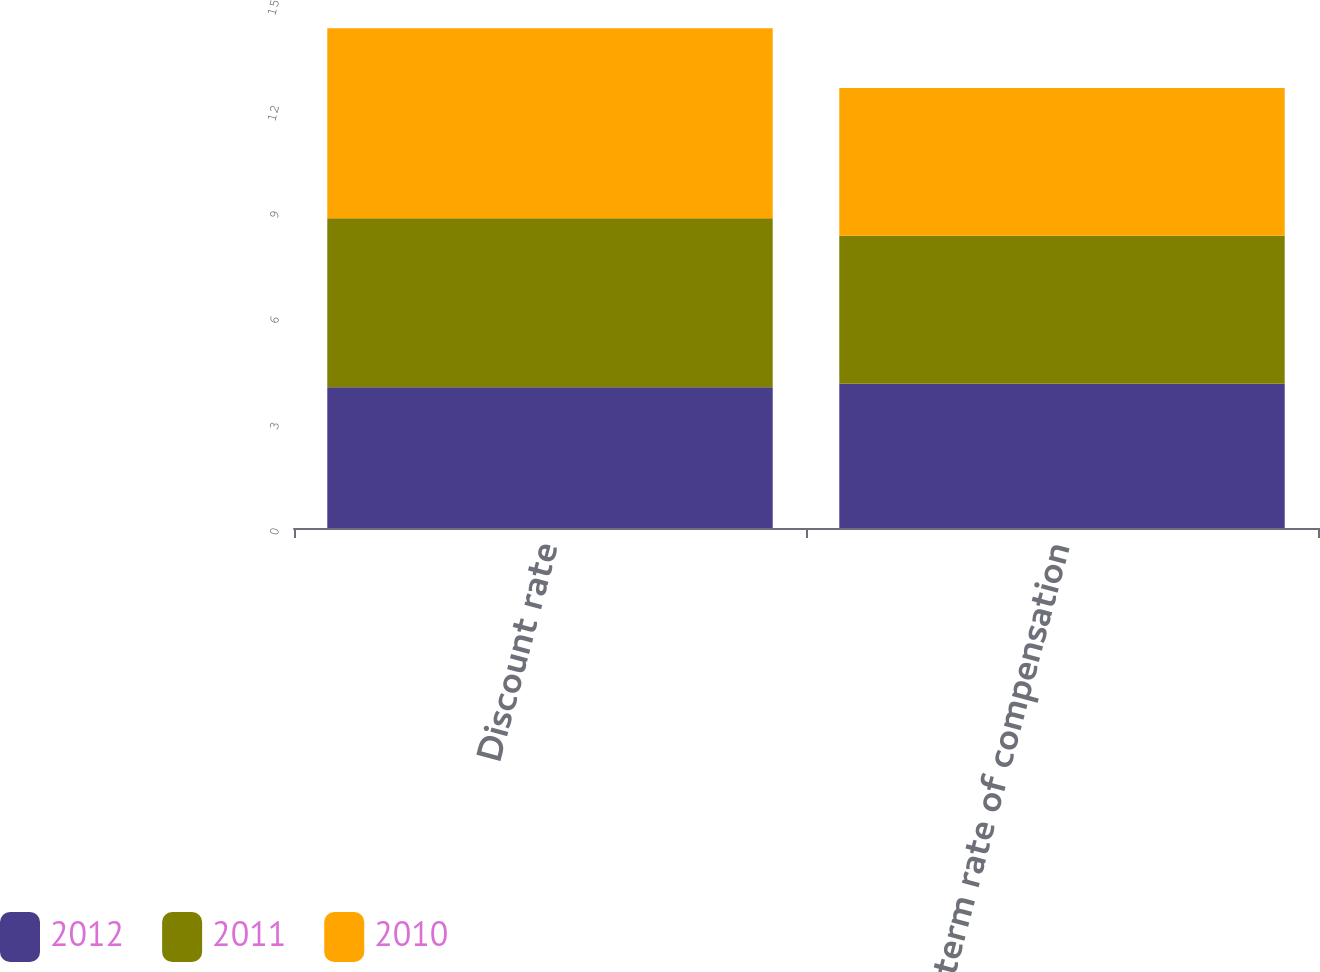<chart> <loc_0><loc_0><loc_500><loc_500><stacked_bar_chart><ecel><fcel>Discount rate<fcel>Long-term rate of compensation<nl><fcel>2012<fcel>4<fcel>4.1<nl><fcel>2011<fcel>4.8<fcel>4.2<nl><fcel>2010<fcel>5.4<fcel>4.2<nl></chart> 